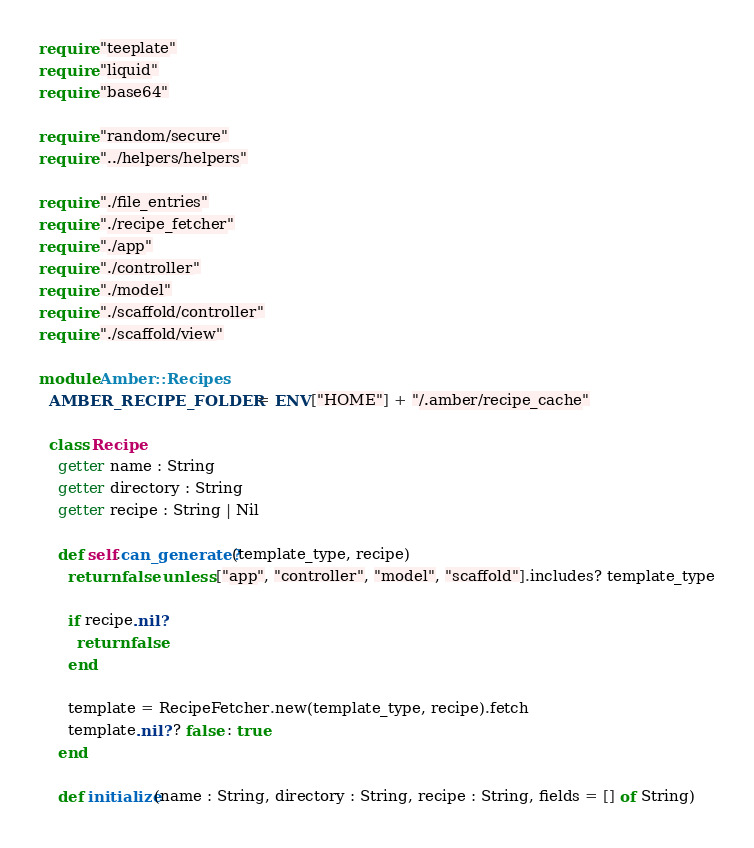<code> <loc_0><loc_0><loc_500><loc_500><_Crystal_>require "teeplate"
require "liquid"
require "base64"

require "random/secure"
require "../helpers/helpers"

require "./file_entries"
require "./recipe_fetcher"
require "./app"
require "./controller"
require "./model"
require "./scaffold/controller"
require "./scaffold/view"

module Amber::Recipes
  AMBER_RECIPE_FOLDER = ENV["HOME"] + "/.amber/recipe_cache"

  class Recipe
    getter name : String
    getter directory : String
    getter recipe : String | Nil

    def self.can_generate?(template_type, recipe)
      return false unless ["app", "controller", "model", "scaffold"].includes? template_type

      if recipe.nil?
        return false
      end

      template = RecipeFetcher.new(template_type, recipe).fetch
      template.nil? ? false : true
    end

    def initialize(name : String, directory : String, recipe : String, fields = [] of String)</code> 